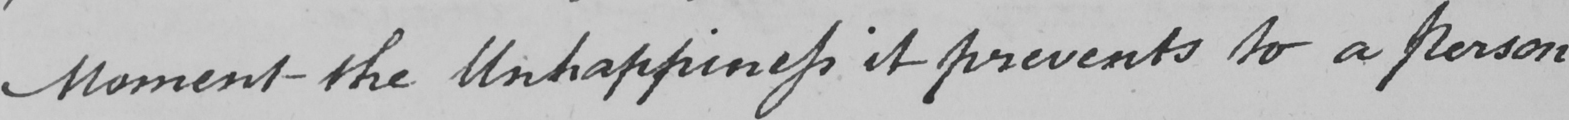Please transcribe the handwritten text in this image. moment the Unhappiness it prevents to a Person 